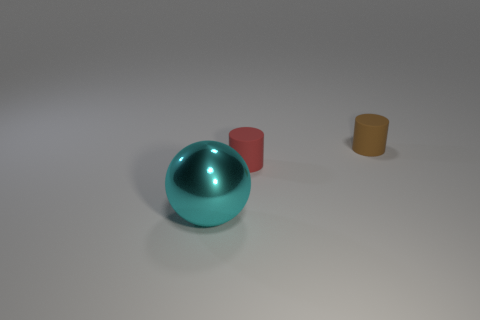Add 2 metal things. How many objects exist? 5 Subtract all brown cylinders. How many cylinders are left? 1 Subtract all cylinders. How many objects are left? 1 Add 2 tiny cyan spheres. How many tiny cyan spheres exist? 2 Subtract 0 gray balls. How many objects are left? 3 Subtract 1 spheres. How many spheres are left? 0 Subtract all yellow cylinders. Subtract all gray spheres. How many cylinders are left? 2 Subtract all rubber cylinders. Subtract all tiny red cylinders. How many objects are left? 0 Add 3 rubber cylinders. How many rubber cylinders are left? 5 